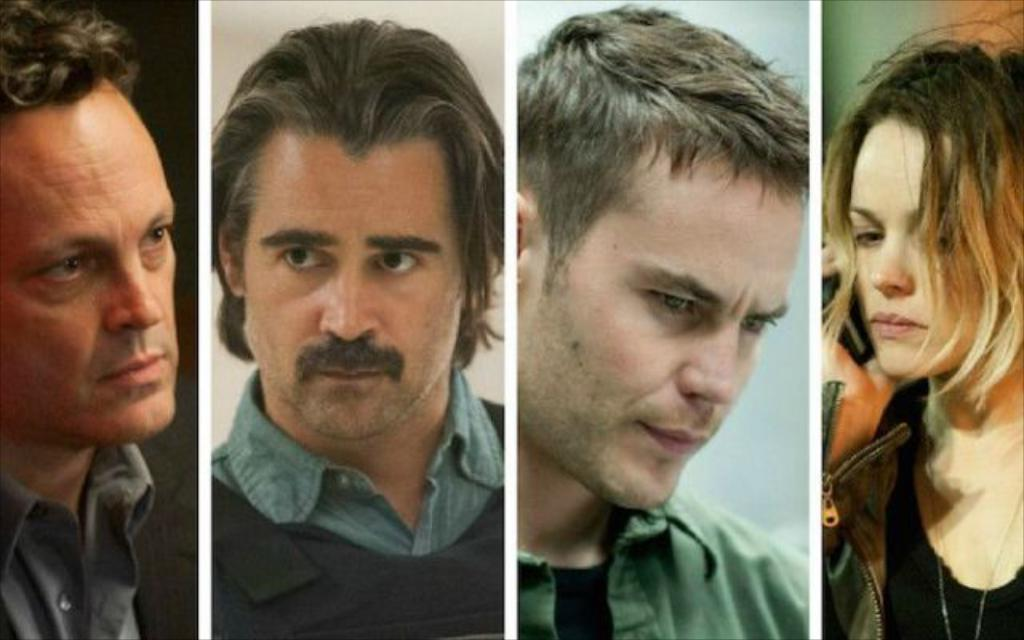What type of image is being described? The image is a collage. How many pictures are included in the collage? There are four pictures in the collage. What can be observed about the subjects in the pictures? Three of the pictures depict men, and one of the pictures depicts a woman. How many feet are visible in the collage? There is no information about feet in the provided facts, so it cannot be determined how many feet are visible in the collage. 